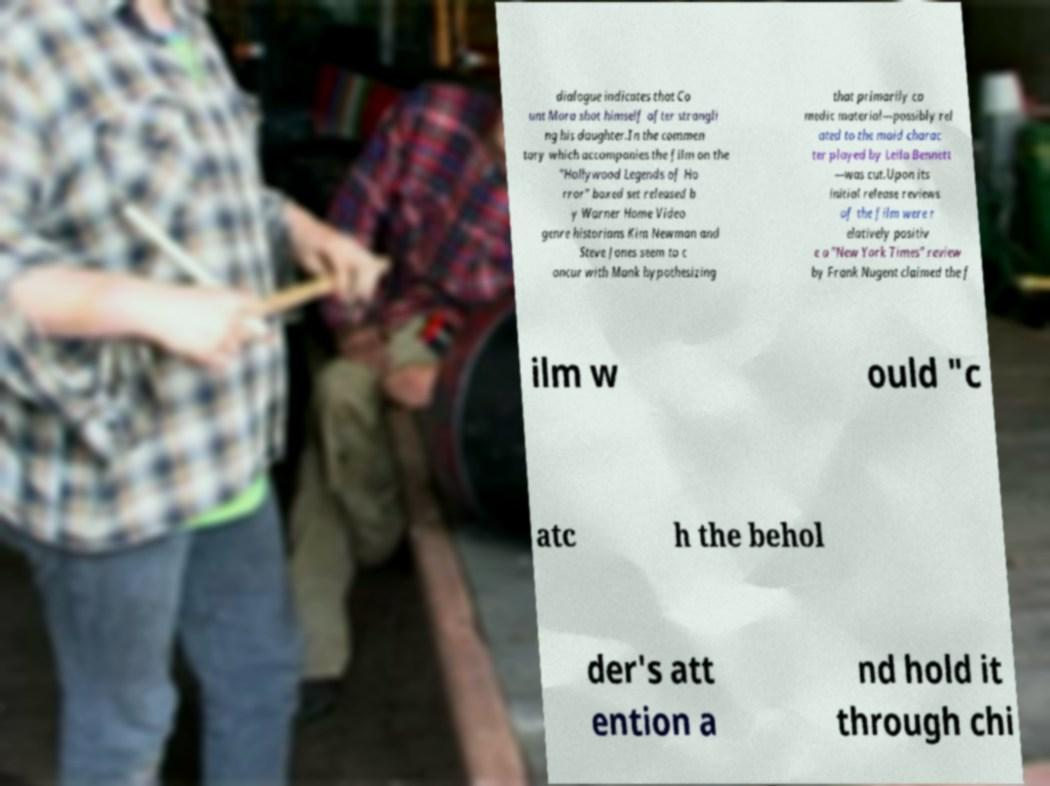Could you assist in decoding the text presented in this image and type it out clearly? dialogue indicates that Co unt Mora shot himself after strangli ng his daughter.In the commen tary which accompanies the film on the "Hollywood Legends of Ho rror" boxed set released b y Warner Home Video genre historians Kim Newman and Steve Jones seem to c oncur with Mank hypothesizing that primarily co medic material—possibly rel ated to the maid charac ter played by Leila Bennett —was cut.Upon its initial release reviews of the film were r elatively positiv e a "New York Times" review by Frank Nugent claimed the f ilm w ould "c atc h the behol der's att ention a nd hold it through chi 